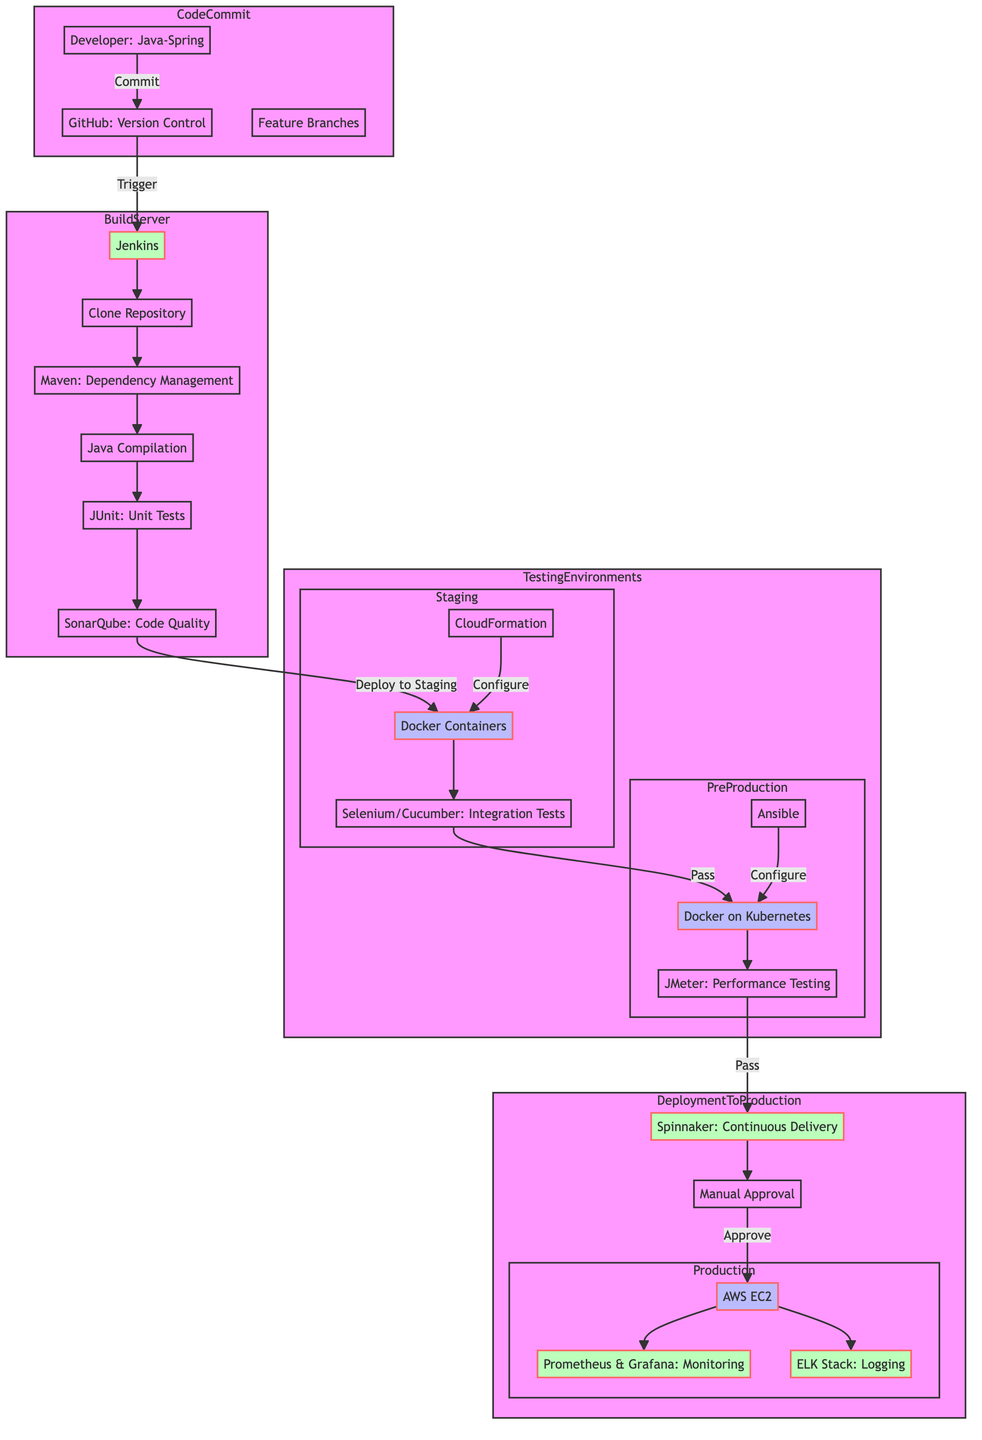What is the version control system used in this CI/CD pipeline? The diagram states that the version control system is GitHub, represented inside the CodeCommit subgraph.
Answer: GitHub How many environments are depicted in the Testing Environments section? In the Testing Environments subgraph, there are two environments specified: Staging and PreProduction, making a total of two environments.
Answer: 2 What tool is used for continuous delivery in the Deployment to Production phase? The diagram indicates that Spinnaker is the tool used for continuous delivery within the DeploymentToProduction subgraph.
Answer: Spinnaker What is the first step in the Build Process? The flowchart outlines that the first step in the Build Process is “Clone Repository,” which connects from Jenkins to the next step.
Answer: Clone Repository What is the infrastructure used in the Staging Environment? According to the diagram, the Staging Environment employs Docker Containers for its infrastructure as illustrated within the Testing Environments section.
Answer: Docker Containers What is the approval process before production deployment? The diagram specifies that there is a Manual Approval process that must occur before deployment to Production, indicated in the DeploymentToProduction section.
Answer: Manual Approval What testing is done in the PreProduction environment? The diagram shows that JMeter is used for Performance Testing in the PreProduction environment, as represented within the respective subgraph.
Answer: JMeter How does the Code Quality Analysis step follow the Unit Tests in the Build Process? The flow of the diagram shows that after the Unit Tests (JUnit) are run, the next step is Code Quality Analysis using SonarQube, indicating a sequential relationship.
Answer: SonarQube How is the Docker in PreProduction environment configured? The diagram indicates that the configuration management for the PreProduction environment is handled by Ansible, as shown in the Testing Environments subgraph.
Answer: Ansible 